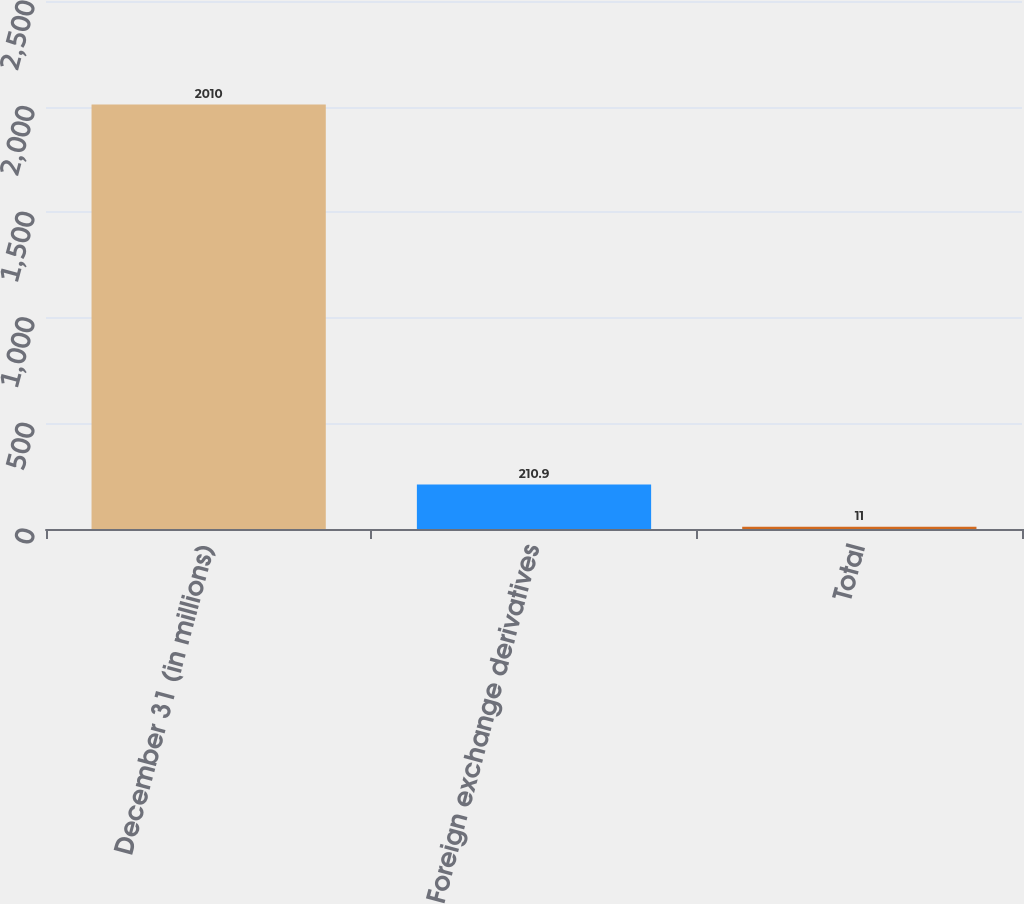Convert chart to OTSL. <chart><loc_0><loc_0><loc_500><loc_500><bar_chart><fcel>December 31 (in millions)<fcel>Foreign exchange derivatives<fcel>Total<nl><fcel>2010<fcel>210.9<fcel>11<nl></chart> 